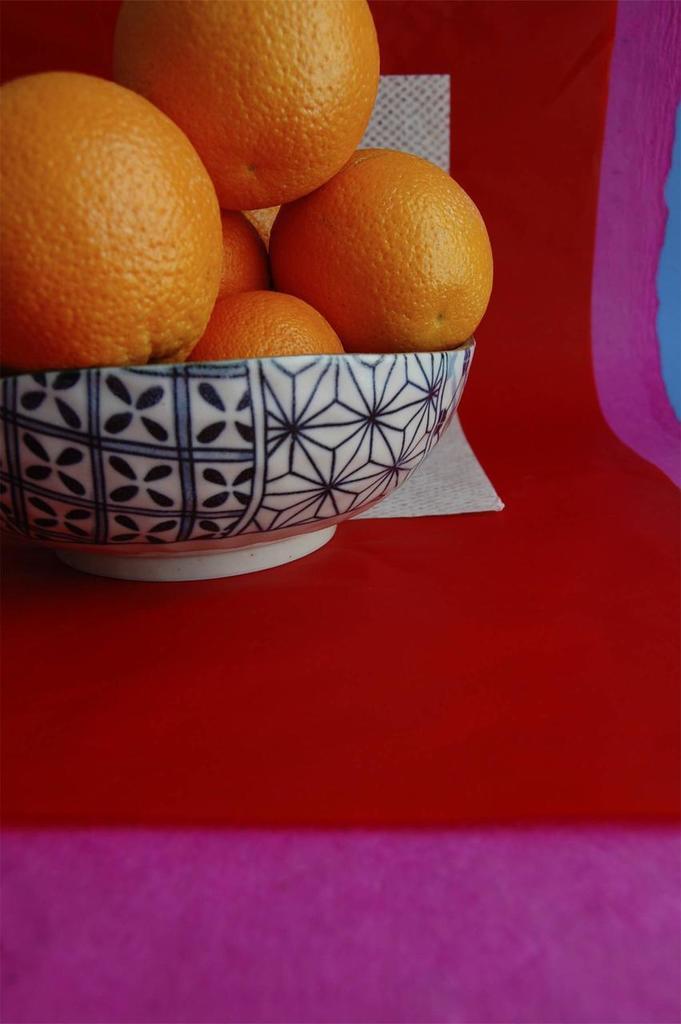Please provide a concise description of this image. In this picture we can see fruits in a bowl and paper on red cloth. 